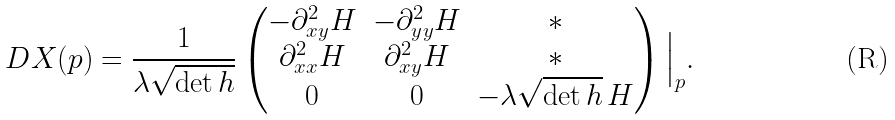<formula> <loc_0><loc_0><loc_500><loc_500>D X ( p ) = \frac { 1 } { \lambda \sqrt { \det h } } \begin{pmatrix} - \partial ^ { 2 } _ { x y } H & - \partial ^ { 2 } _ { y y } H & * \\ \partial ^ { 2 } _ { x x } H & \partial ^ { 2 } _ { x y } H & * \\ 0 & 0 & - \lambda \sqrt { \det h } \, H \end{pmatrix} \Big | _ { p } .</formula> 